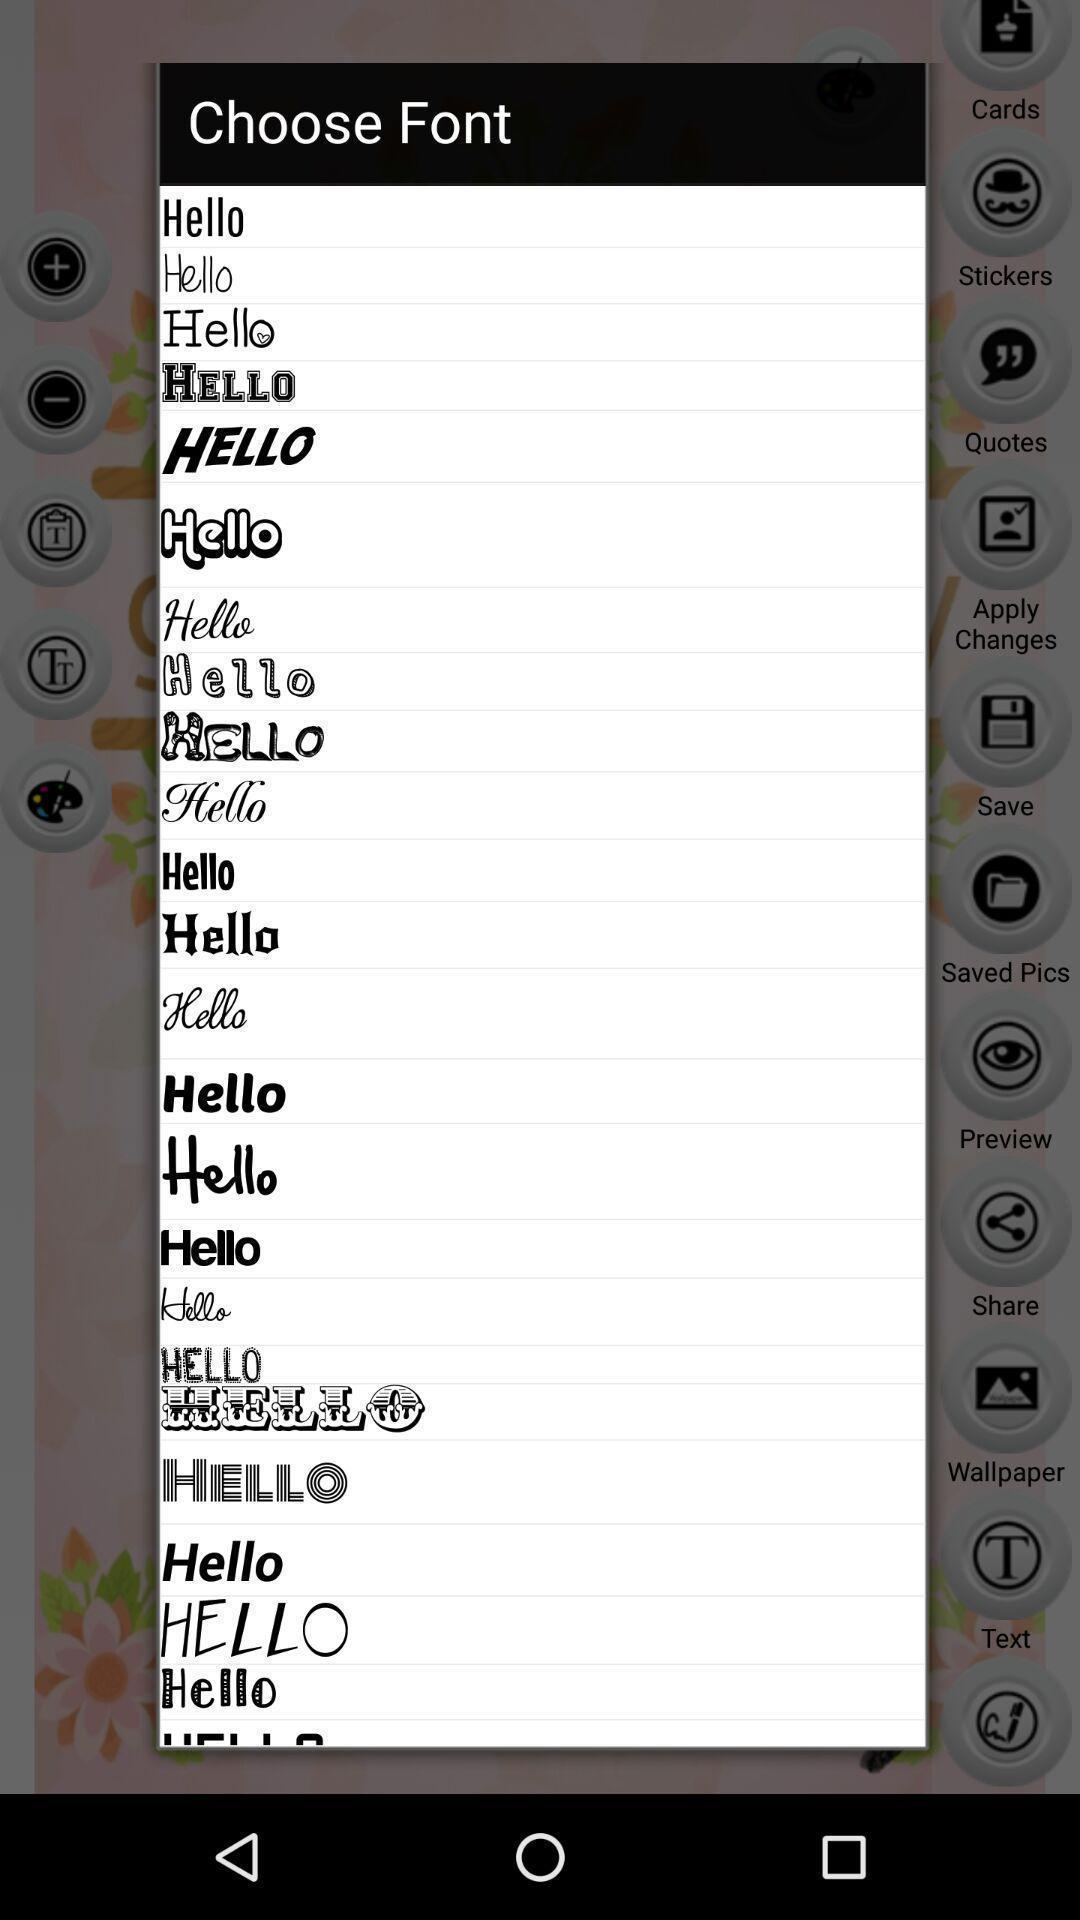Summarize the information in this screenshot. Pop-up shows choose font from list. 